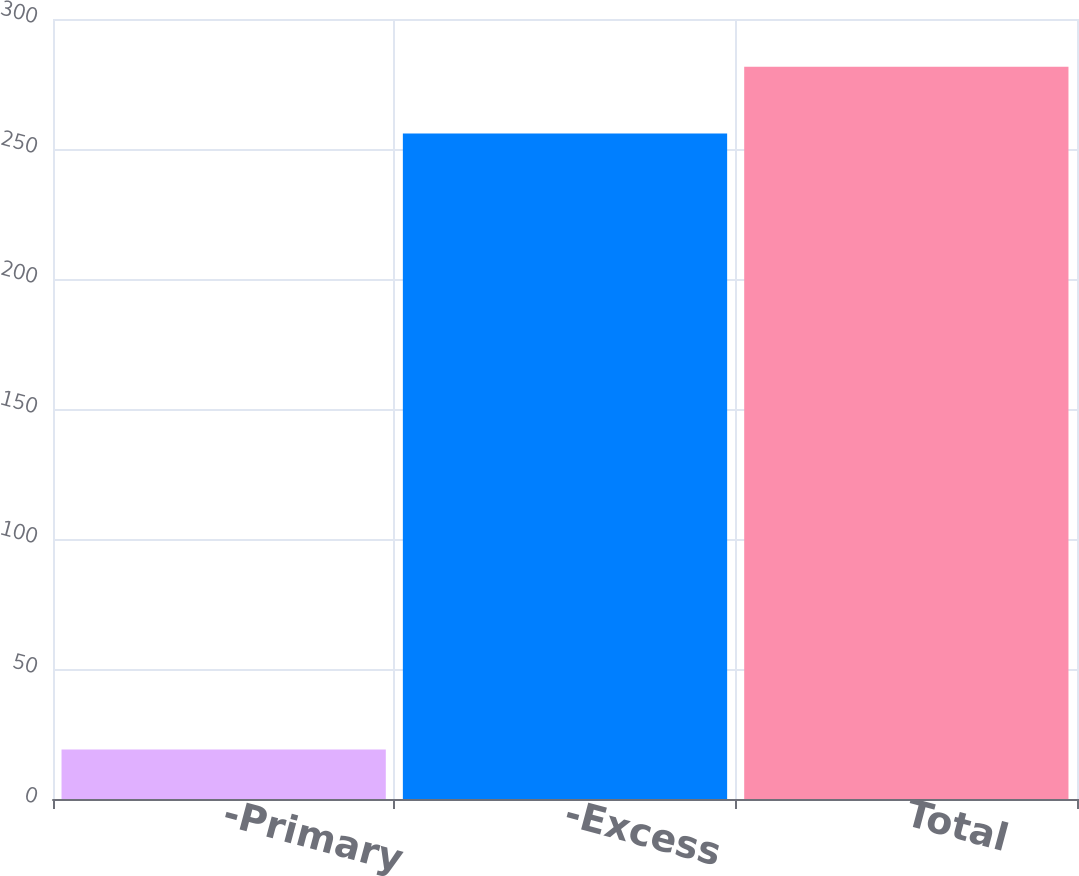Convert chart. <chart><loc_0><loc_0><loc_500><loc_500><bar_chart><fcel>-Primary<fcel>-Excess<fcel>Total<nl><fcel>19<fcel>256<fcel>281.6<nl></chart> 